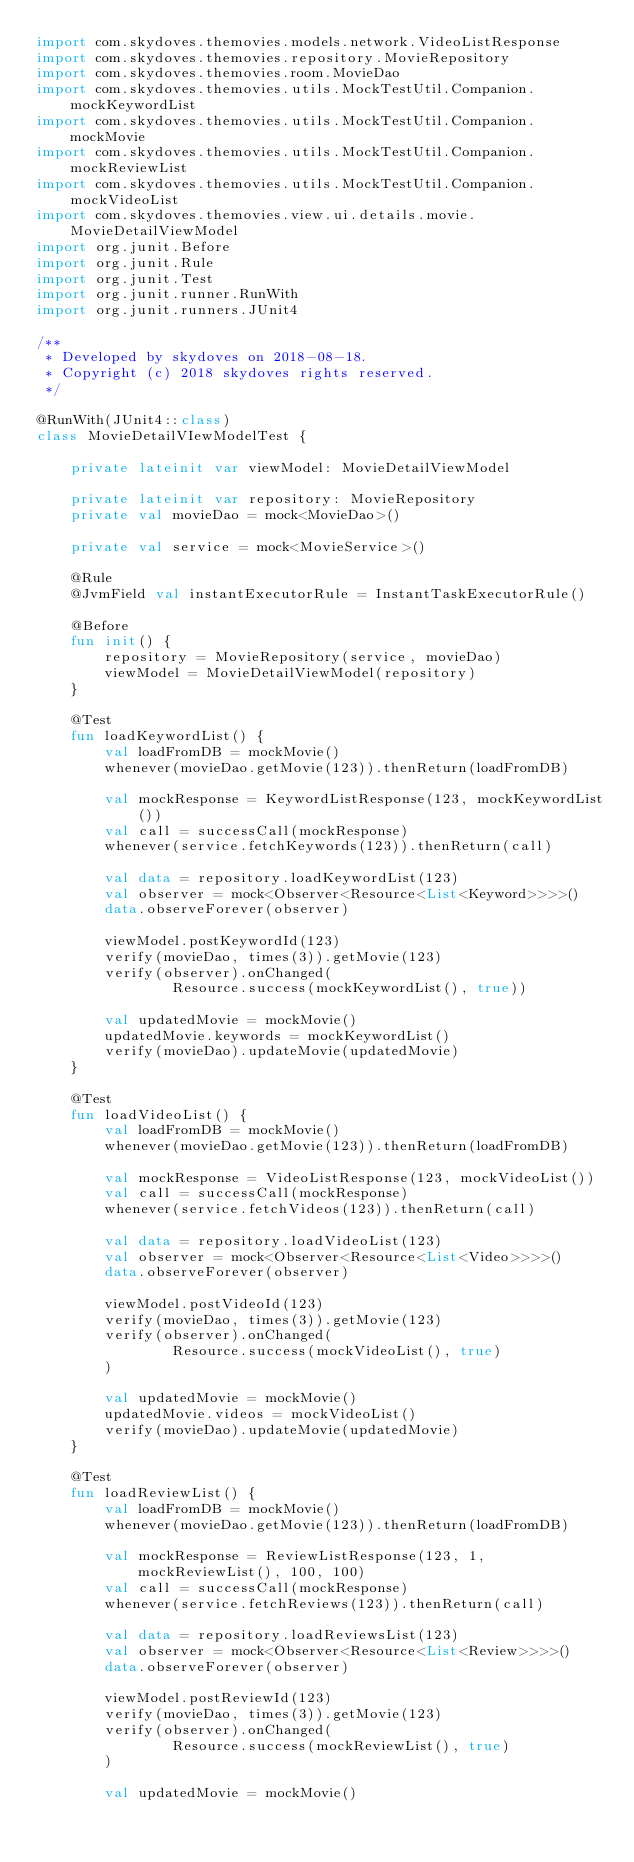<code> <loc_0><loc_0><loc_500><loc_500><_Kotlin_>import com.skydoves.themovies.models.network.VideoListResponse
import com.skydoves.themovies.repository.MovieRepository
import com.skydoves.themovies.room.MovieDao
import com.skydoves.themovies.utils.MockTestUtil.Companion.mockKeywordList
import com.skydoves.themovies.utils.MockTestUtil.Companion.mockMovie
import com.skydoves.themovies.utils.MockTestUtil.Companion.mockReviewList
import com.skydoves.themovies.utils.MockTestUtil.Companion.mockVideoList
import com.skydoves.themovies.view.ui.details.movie.MovieDetailViewModel
import org.junit.Before
import org.junit.Rule
import org.junit.Test
import org.junit.runner.RunWith
import org.junit.runners.JUnit4

/**
 * Developed by skydoves on 2018-08-18.
 * Copyright (c) 2018 skydoves rights reserved.
 */

@RunWith(JUnit4::class)
class MovieDetailVIewModelTest {

    private lateinit var viewModel: MovieDetailViewModel

    private lateinit var repository: MovieRepository
    private val movieDao = mock<MovieDao>()

    private val service = mock<MovieService>()

    @Rule
    @JvmField val instantExecutorRule = InstantTaskExecutorRule()

    @Before
    fun init() {
        repository = MovieRepository(service, movieDao)
        viewModel = MovieDetailViewModel(repository)
    }

    @Test
    fun loadKeywordList() {
        val loadFromDB = mockMovie()
        whenever(movieDao.getMovie(123)).thenReturn(loadFromDB)

        val mockResponse = KeywordListResponse(123, mockKeywordList())
        val call = successCall(mockResponse)
        whenever(service.fetchKeywords(123)).thenReturn(call)

        val data = repository.loadKeywordList(123)
        val observer = mock<Observer<Resource<List<Keyword>>>>()
        data.observeForever(observer)

        viewModel.postKeywordId(123)
        verify(movieDao, times(3)).getMovie(123)
        verify(observer).onChanged(
                Resource.success(mockKeywordList(), true))

        val updatedMovie = mockMovie()
        updatedMovie.keywords = mockKeywordList()
        verify(movieDao).updateMovie(updatedMovie)
    }

    @Test
    fun loadVideoList() {
        val loadFromDB = mockMovie()
        whenever(movieDao.getMovie(123)).thenReturn(loadFromDB)

        val mockResponse = VideoListResponse(123, mockVideoList())
        val call = successCall(mockResponse)
        whenever(service.fetchVideos(123)).thenReturn(call)

        val data = repository.loadVideoList(123)
        val observer = mock<Observer<Resource<List<Video>>>>()
        data.observeForever(observer)

        viewModel.postVideoId(123)
        verify(movieDao, times(3)).getMovie(123)
        verify(observer).onChanged(
                Resource.success(mockVideoList(), true)
        )

        val updatedMovie = mockMovie()
        updatedMovie.videos = mockVideoList()
        verify(movieDao).updateMovie(updatedMovie)
    }

    @Test
    fun loadReviewList() {
        val loadFromDB = mockMovie()
        whenever(movieDao.getMovie(123)).thenReturn(loadFromDB)

        val mockResponse = ReviewListResponse(123, 1, mockReviewList(), 100, 100)
        val call = successCall(mockResponse)
        whenever(service.fetchReviews(123)).thenReturn(call)

        val data = repository.loadReviewsList(123)
        val observer = mock<Observer<Resource<List<Review>>>>()
        data.observeForever(observer)

        viewModel.postReviewId(123)
        verify(movieDao, times(3)).getMovie(123)
        verify(observer).onChanged(
                Resource.success(mockReviewList(), true)
        )

        val updatedMovie = mockMovie()</code> 